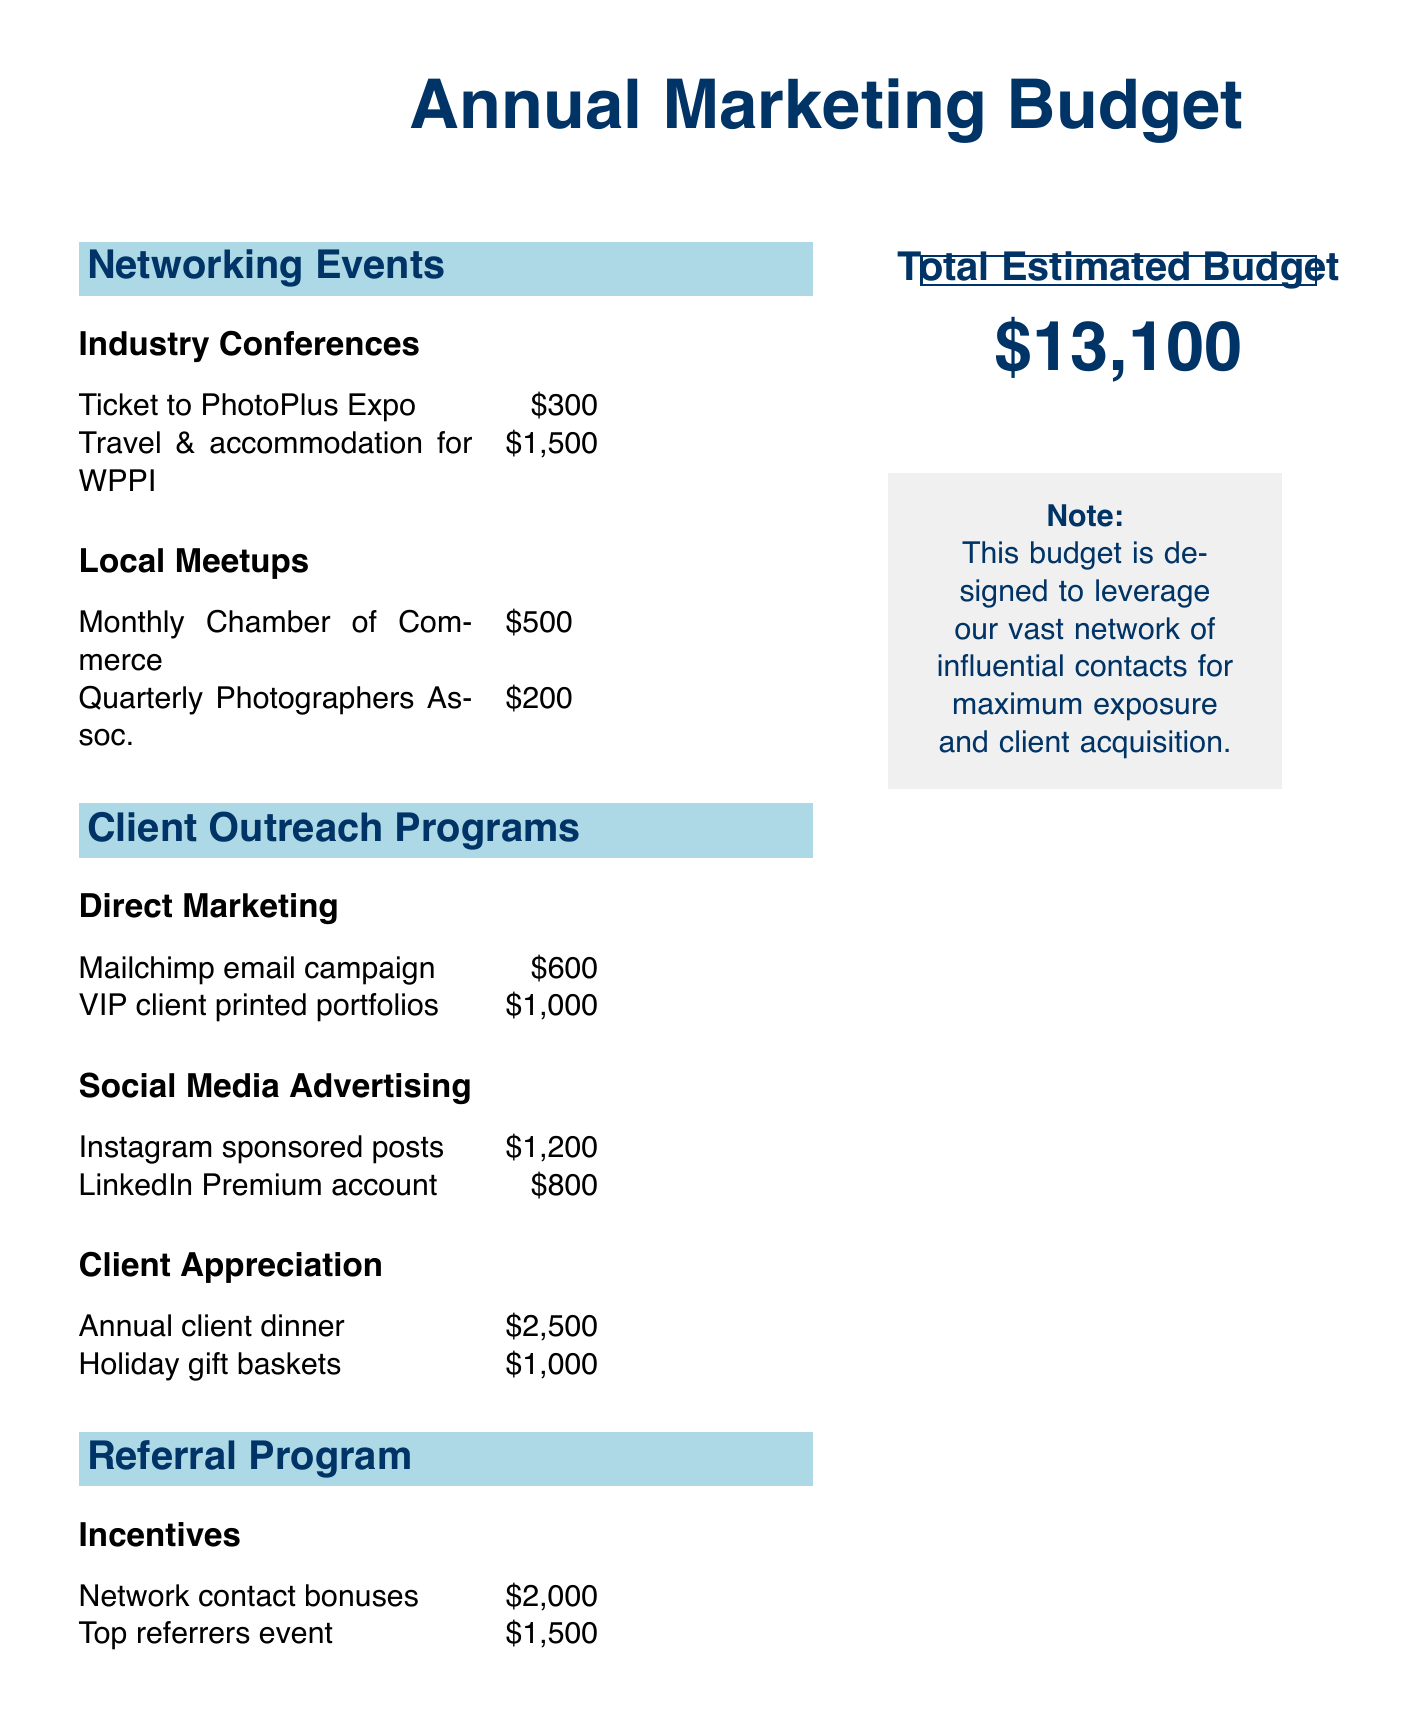What is the total estimated budget? The total estimated budget is stated at the bottom of the document, summarizing all expenses.
Answer: $13,100 How much is allocated for the Annual client dinner? The budget section for Client Appreciation specifies the cost for the Annual client dinner.
Answer: $2,500 What is the cost of the Mailchimp email campaign? The Direct Marketing subsection lists the expense for the Mailchimp email campaign.
Answer: $600 How many local meetups are listed? The Local Meetups section provides two entries for monthly and quarterly meetings, indicating the count.
Answer: 2 What is the amount set for Network contact bonuses? The Referral Program section specifies the amount designated for Network contact bonuses.
Answer: $2,000 Which social media platform has a higher advertising budget? A comparison of the Instagram and LinkedIn sections reveals differing costs for advertising on each platform.
Answer: Instagram What is the total cost for Local Meetups? Summing the individual costs in the Local Meetups section reveals the total expense for that category.
Answer: $700 What is the budget allocated for holiday gift baskets? The Client Appreciation section describes the expense set aside for holiday gift baskets.
Answer: $1,000 How many types of Client Appreciation events are listed? The Client Appreciation section categorizes different events and total offerings.
Answer: 2 What program is established to promote referrals? The document details a specific program to incentivize referrals and boost client outreach.
Answer: Referral Program 